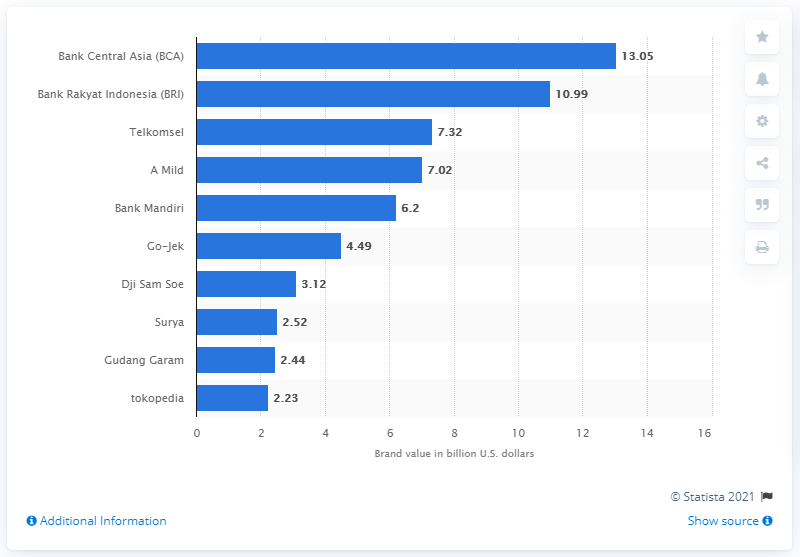Which Indonesian brand comes second after Bank Central Asia in terms of brand value according to the chart? As shown in the chart, the brand that comes second after Bank Central Asia in terms of brand value is Bank Rakyat Indonesia (BRI), with a brand value of 10.99 billion U.S. dollars. 